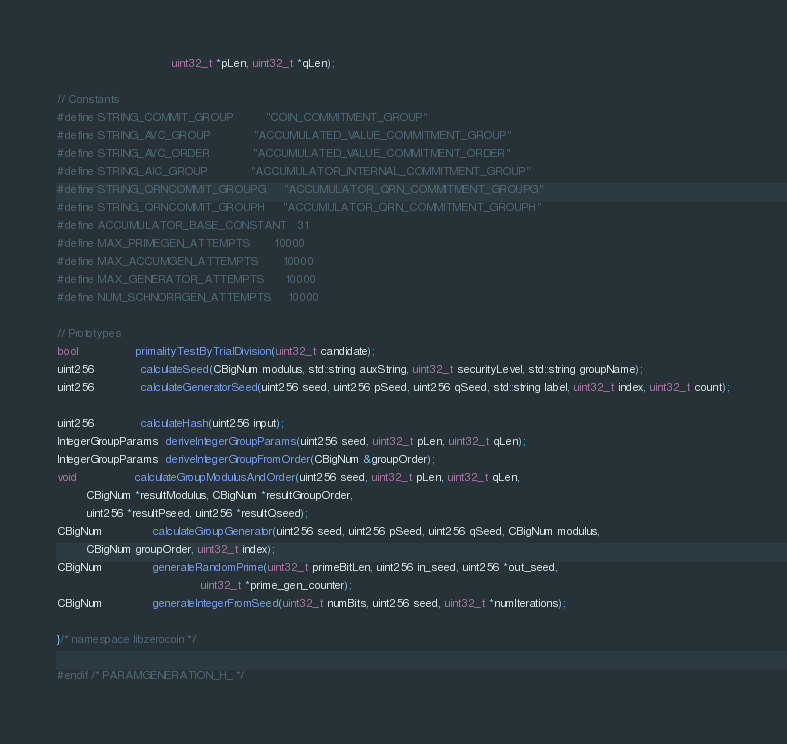Convert code to text. <code><loc_0><loc_0><loc_500><loc_500><_C_>                                uint32_t *pLen, uint32_t *qLen);

// Constants
#define STRING_COMMIT_GROUP         "COIN_COMMITMENT_GROUP"
#define STRING_AVC_GROUP            "ACCUMULATED_VALUE_COMMITMENT_GROUP"
#define STRING_AVC_ORDER            "ACCUMULATED_VALUE_COMMITMENT_ORDER"
#define STRING_AIC_GROUP            "ACCUMULATOR_INTERNAL_COMMITMENT_GROUP"
#define STRING_QRNCOMMIT_GROUPG     "ACCUMULATOR_QRN_COMMITMENT_GROUPG"
#define STRING_QRNCOMMIT_GROUPH     "ACCUMULATOR_QRN_COMMITMENT_GROUPH"
#define ACCUMULATOR_BASE_CONSTANT   31
#define MAX_PRIMEGEN_ATTEMPTS       10000
#define MAX_ACCUMGEN_ATTEMPTS       10000
#define MAX_GENERATOR_ATTEMPTS      10000
#define NUM_SCHNORRGEN_ATTEMPTS     10000

// Prototypes
bool                primalityTestByTrialDivision(uint32_t candidate);
uint256             calculateSeed(CBigNum modulus, std::string auxString, uint32_t securityLevel, std::string groupName);
uint256             calculateGeneratorSeed(uint256 seed, uint256 pSeed, uint256 qSeed, std::string label, uint32_t index, uint32_t count);

uint256             calculateHash(uint256 input);
IntegerGroupParams  deriveIntegerGroupParams(uint256 seed, uint32_t pLen, uint32_t qLen);
IntegerGroupParams  deriveIntegerGroupFromOrder(CBigNum &groupOrder);
void                calculateGroupModulusAndOrder(uint256 seed, uint32_t pLen, uint32_t qLen,
        CBigNum *resultModulus, CBigNum *resultGroupOrder,
        uint256 *resultPseed, uint256 *resultQseed);
CBigNum              calculateGroupGenerator(uint256 seed, uint256 pSeed, uint256 qSeed, CBigNum modulus,
        CBigNum groupOrder, uint32_t index);
CBigNum              generateRandomPrime(uint32_t primeBitLen, uint256 in_seed, uint256 *out_seed,
                                        uint32_t *prime_gen_counter);
CBigNum              generateIntegerFromSeed(uint32_t numBits, uint256 seed, uint32_t *numIterations);

}/* namespace libzerocoin */

#endif /* PARAMGENERATION_H_ */
</code> 